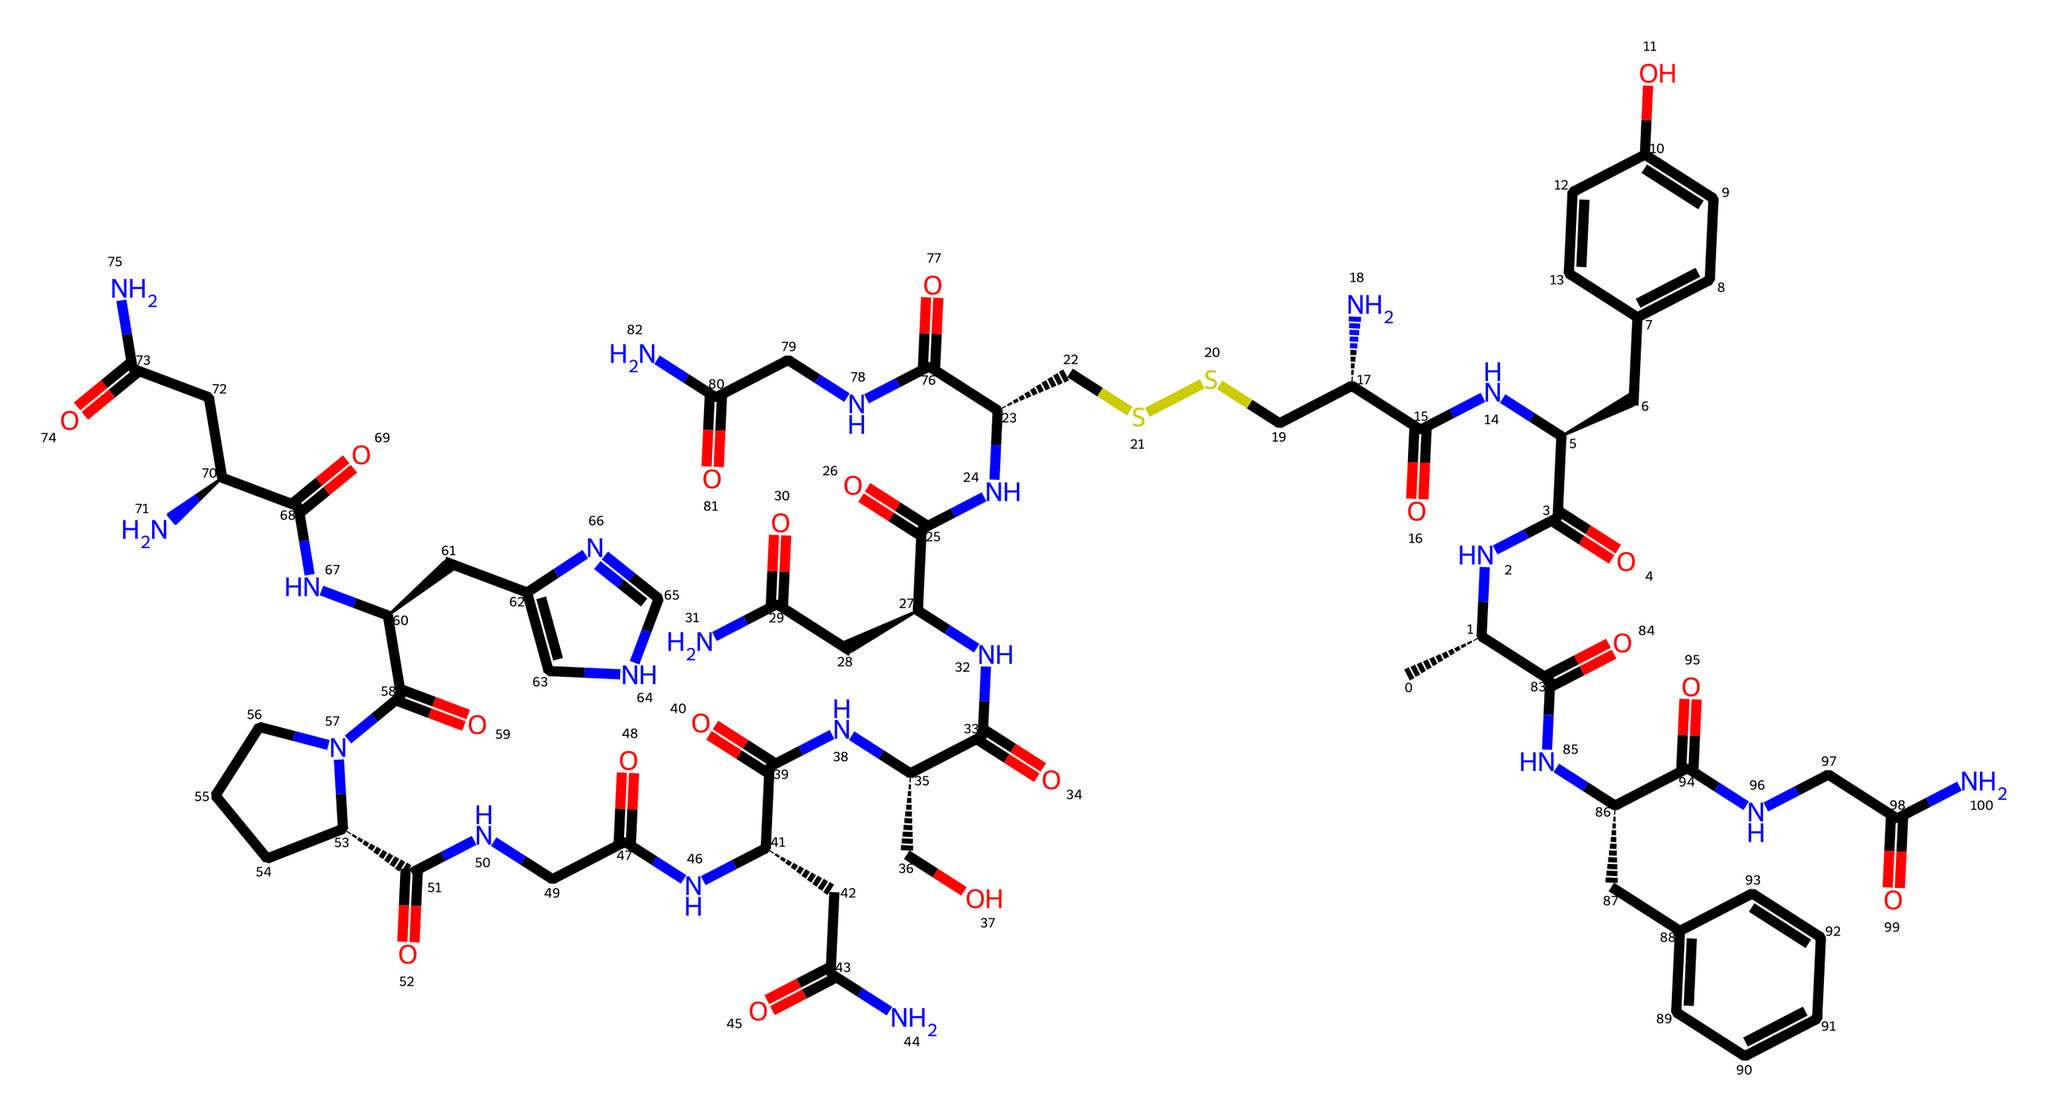What is the molecular weight of oxytocin? The molecular weight can be calculated by summing the atomic weights of all atoms in the structure. By counting the unique atoms in the SMILES representation, I can determine that the molecular weight of oxytocin is approximately 1,007 Daltons.
Answer: 1,007 Daltons How many nitrogen atoms are present in this structure? By analyzing the SMILES, I can count each nitrogen atom represented in the chemical structure. There are 8 nitrogen atoms present in the chemical formula.
Answer: 8 Is oxytocin a peptide hormone? This chemical is composed of amino acid sequences linked by peptide bonds, which characterizes it as a peptide hormone.
Answer: Yes Which characteristic feature does oxytocin have for promoting bonding? The presence of specific amino acid side chains and certain functional groups, especially the disulfide bond, contributes to oxytocin's ability to promote bonding and emotional connections.
Answer: Disulfide bond What is the main functional group that defines oxytocin as a hormone? The primary functional group in oxytocin's structure is the amide group, which is crucial for its biological activity as a hormone.
Answer: Amide group How many rings are present in the oxytocin structure? Upon carefully reviewing the SMILES representation, I can see that there are no cyclic structures indicated by parentheses or other symbols, confirming that oxytocin is acyclic.
Answer: 0 